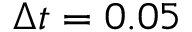Convert formula to latex. <formula><loc_0><loc_0><loc_500><loc_500>\Delta t = 0 . 0 5</formula> 